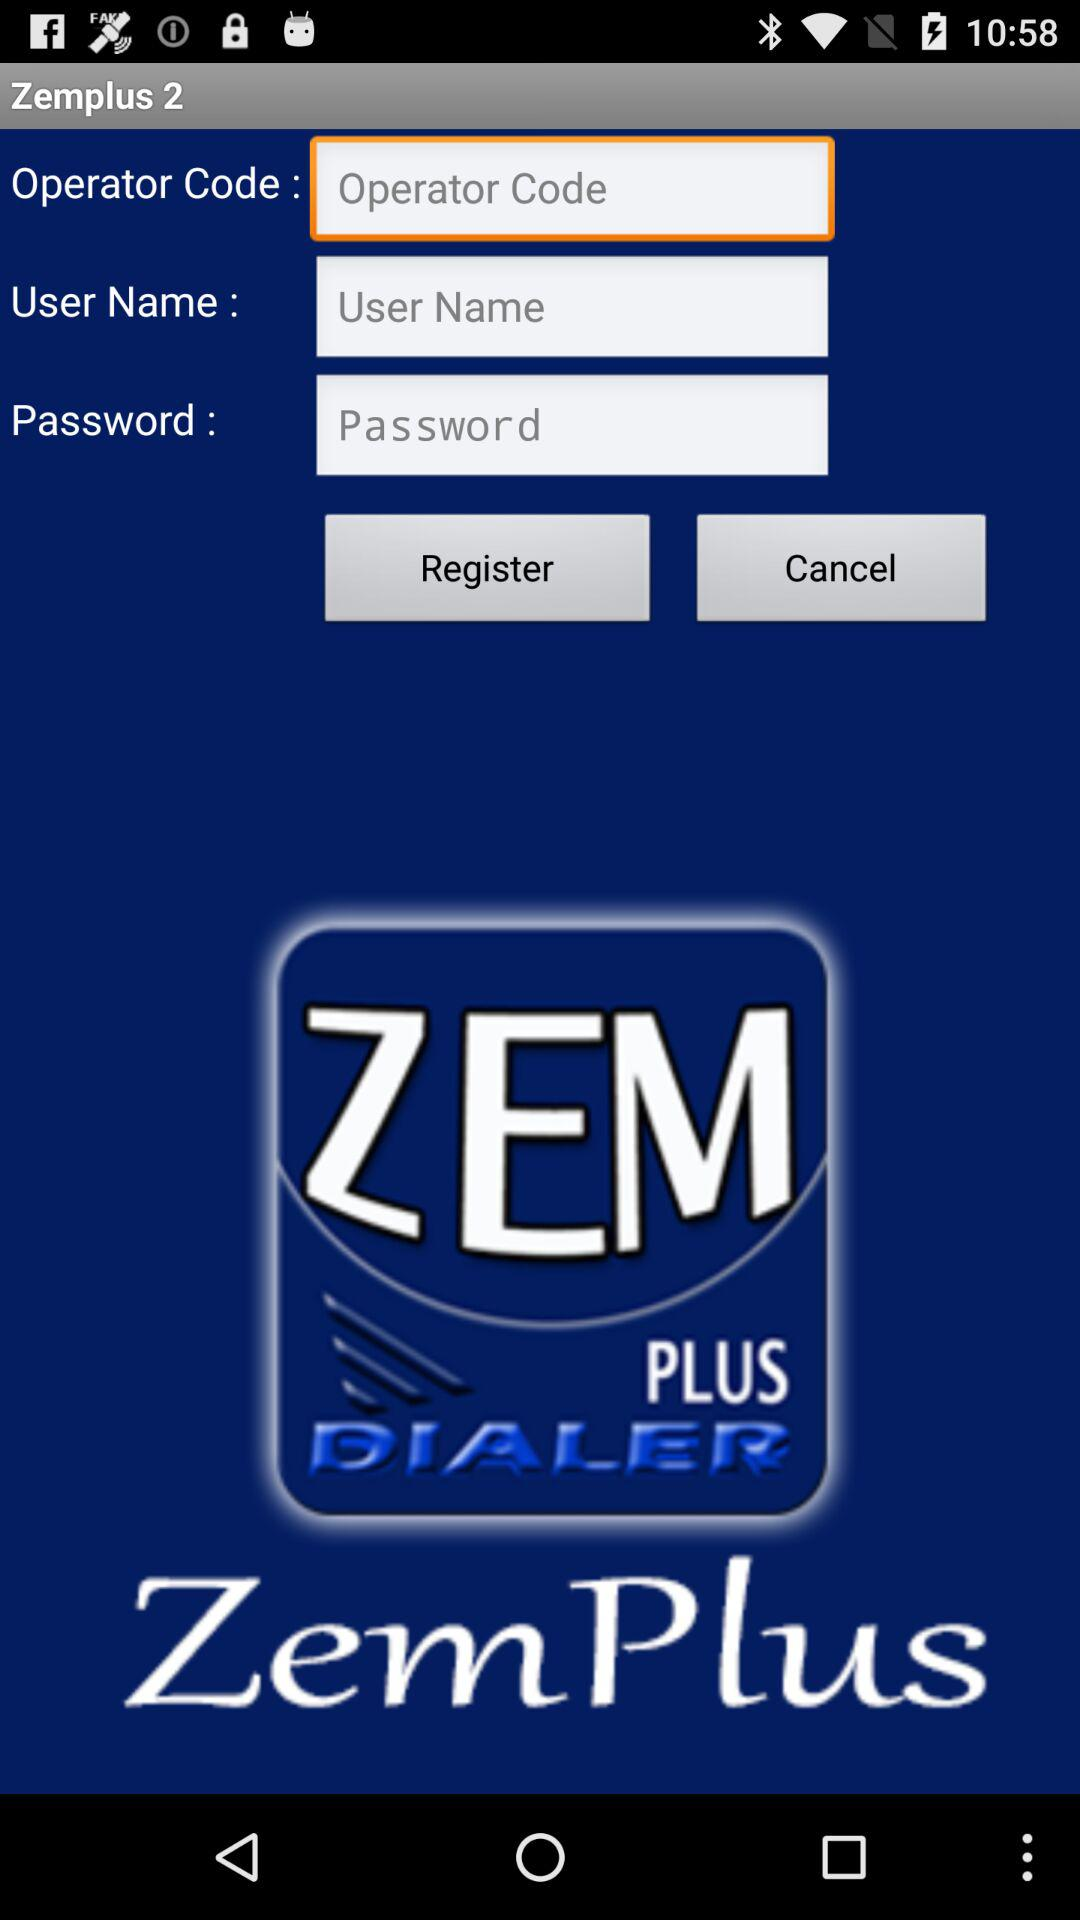How many characters are in the operator code?
When the provided information is insufficient, respond with <no answer>. <no answer> 